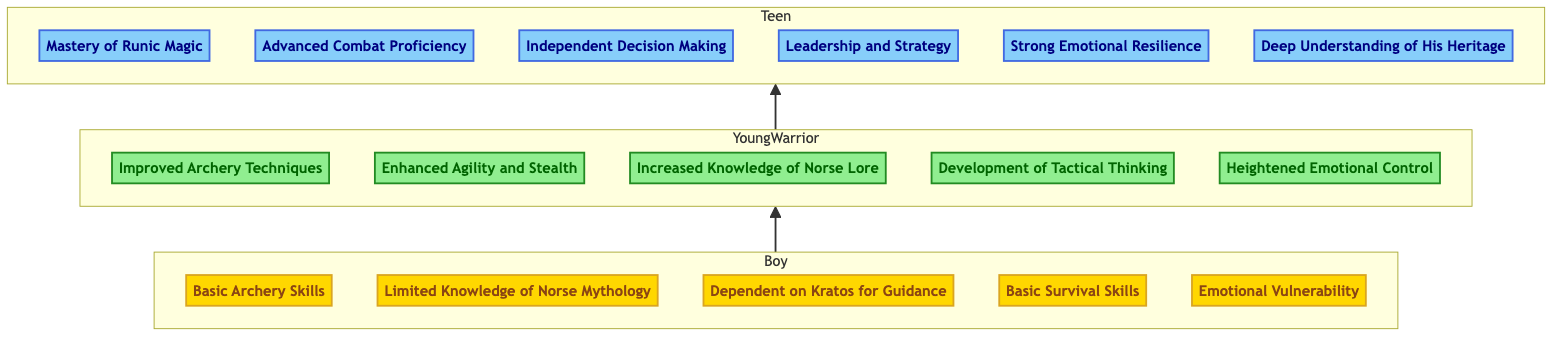What abilities are listed under the "Boy" level? The diagram visually presents the abilities at each level. For the "Boy" level, I can see five abilities listed: "Basic Archery Skills," "Limited Knowledge of Norse Mythology," "Dependent on Kratos for Guidance," "Basic Survival Skills," and "Emotional Vulnerability."
Answer: Basic Archery Skills, Limited Knowledge of Norse Mythology, Dependent on Kratos for Guidance, Basic Survival Skills, Emotional Vulnerability How many abilities does the "Teen" level show? By counting the abilities listed in the "Teen" level on the diagram, I find there are six abilities: "Mastery of Runic Magic," "Advanced Combat Proficiency," "Independent Decision Making," "Leadership and Strategy," "Strong Emotional Resilience," and "Deep Understanding of His Heritage."
Answer: 6 What is the first ability listed in the "Young Warrior" level? The diagram displays the abilities in a specific order within the "Young Warrior" level. The first one listed is "Improved Archery Techniques."
Answer: Improved Archery Techniques How does "Emotional Vulnerability" transform to "Heightened Emotional Control" from Boy to Young Warrior? To answer this, I examine how the emotions portrayed in each level progress. Starting from "Emotional Vulnerability" at the "Boy" level, it suggests a state of being easily affected by emotions, which evolves into "Heightened Emotional Control" at the "Young Warrior" level, implying better management of emotions. Thus, this represents an improvement in emotional maturity and resilience.
Answer: Emotional growth What is the relationship between "Young Warrior" and "Teen" levels? The diagram indicates a direct upward arrow from "Young Warrior" to "Teen," which denotes a progression in Atreus' abilities as he matures. This signifies that the abilities and experiences from the "Young Warrior" level contribute to the development of more advanced abilities in the "Teen" level.
Answer: Progression Which ability indicates independence in the "Teen" level? Looking at the abilities listed under the "Teen" level, "Independent Decision Making" clearly signifies Atreus' growth into making choices without reliance on others, showcasing a key aspect of personal development and independence.
Answer: Independent Decision Making 